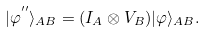<formula> <loc_0><loc_0><loc_500><loc_500>| \varphi ^ { ^ { \prime \prime } } \rangle _ { A B } = ( I _ { A } \otimes V _ { B } ) | \varphi \rangle _ { A B } .</formula> 